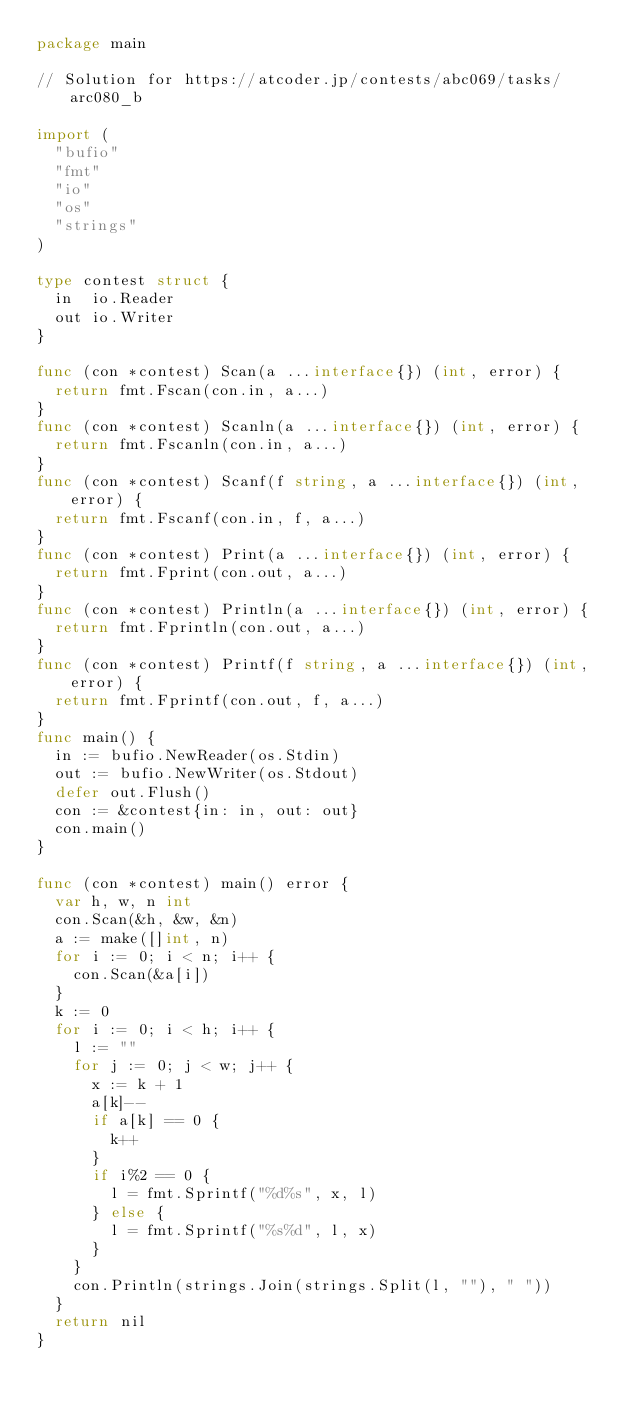Convert code to text. <code><loc_0><loc_0><loc_500><loc_500><_Go_>package main

// Solution for https://atcoder.jp/contests/abc069/tasks/arc080_b

import (
	"bufio"
	"fmt"
	"io"
	"os"
	"strings"
)

type contest struct {
	in  io.Reader
	out io.Writer
}

func (con *contest) Scan(a ...interface{}) (int, error) {
	return fmt.Fscan(con.in, a...)
}
func (con *contest) Scanln(a ...interface{}) (int, error) {
	return fmt.Fscanln(con.in, a...)
}
func (con *contest) Scanf(f string, a ...interface{}) (int, error) {
	return fmt.Fscanf(con.in, f, a...)
}
func (con *contest) Print(a ...interface{}) (int, error) {
	return fmt.Fprint(con.out, a...)
}
func (con *contest) Println(a ...interface{}) (int, error) {
	return fmt.Fprintln(con.out, a...)
}
func (con *contest) Printf(f string, a ...interface{}) (int, error) {
	return fmt.Fprintf(con.out, f, a...)
}
func main() {
	in := bufio.NewReader(os.Stdin)
	out := bufio.NewWriter(os.Stdout)
	defer out.Flush()
	con := &contest{in: in, out: out}
	con.main()
}

func (con *contest) main() error {
	var h, w, n int
	con.Scan(&h, &w, &n)
	a := make([]int, n)
	for i := 0; i < n; i++ {
		con.Scan(&a[i])
	}
	k := 0
	for i := 0; i < h; i++ {
		l := ""
		for j := 0; j < w; j++ {
			x := k + 1
			a[k]--
			if a[k] == 0 {
				k++
			}
			if i%2 == 0 {
				l = fmt.Sprintf("%d%s", x, l)
			} else {
				l = fmt.Sprintf("%s%d", l, x)
			}
		}
		con.Println(strings.Join(strings.Split(l, ""), " "))
	}
	return nil
}
</code> 